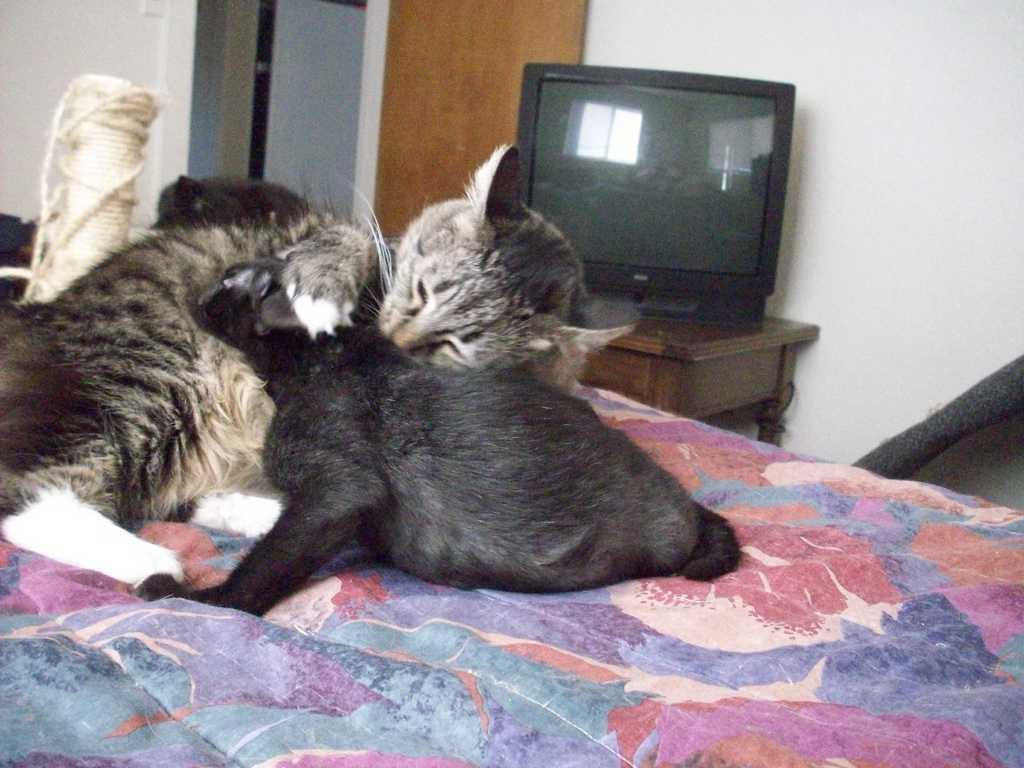How many cats are present in the image? There are three cats on the bed. What type of furniture is visible in the image? There is a wooden table in the image. What is placed on the wooden table? There is a television on the wooden table. What type of lip balm can be seen on the television in the image? There is no lip balm present on the television in the image. 